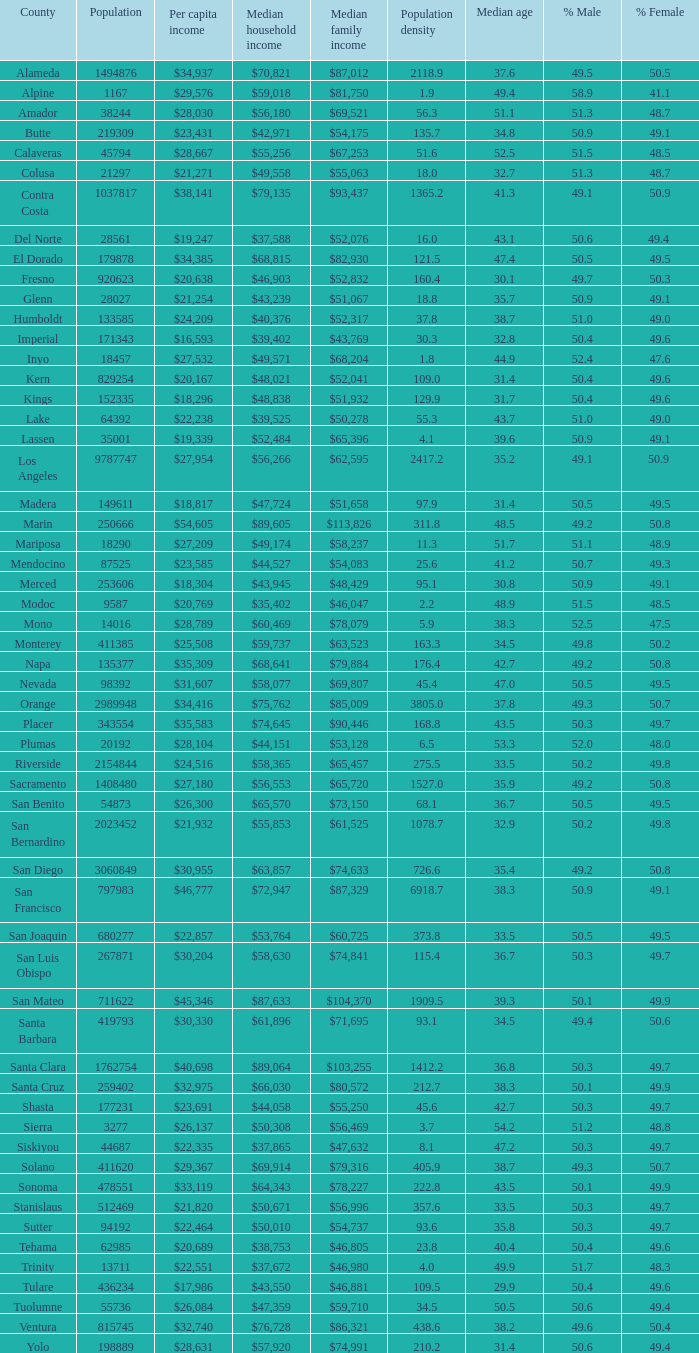What is the median household income of butte? $42,971. 